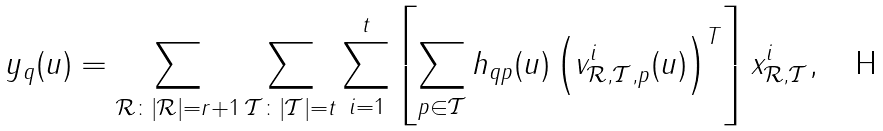<formula> <loc_0><loc_0><loc_500><loc_500>y _ { q } ( u ) & = \sum _ { \mathcal { R } \colon | \mathcal { R } | = r + 1 } \sum _ { \mathcal { T } \colon | \mathcal { T } | = t } \sum _ { i = 1 } ^ { t } \left [ \sum _ { p \in \mathcal { T } } h _ { q p } ( u ) \left ( v _ { { \mathcal { R } } , { \mathcal { T } } , p } ^ { i } ( u ) \right ) ^ { T } \right ] x _ { { \mathcal { R } } , { \mathcal { T } } } ^ { i } ,</formula> 